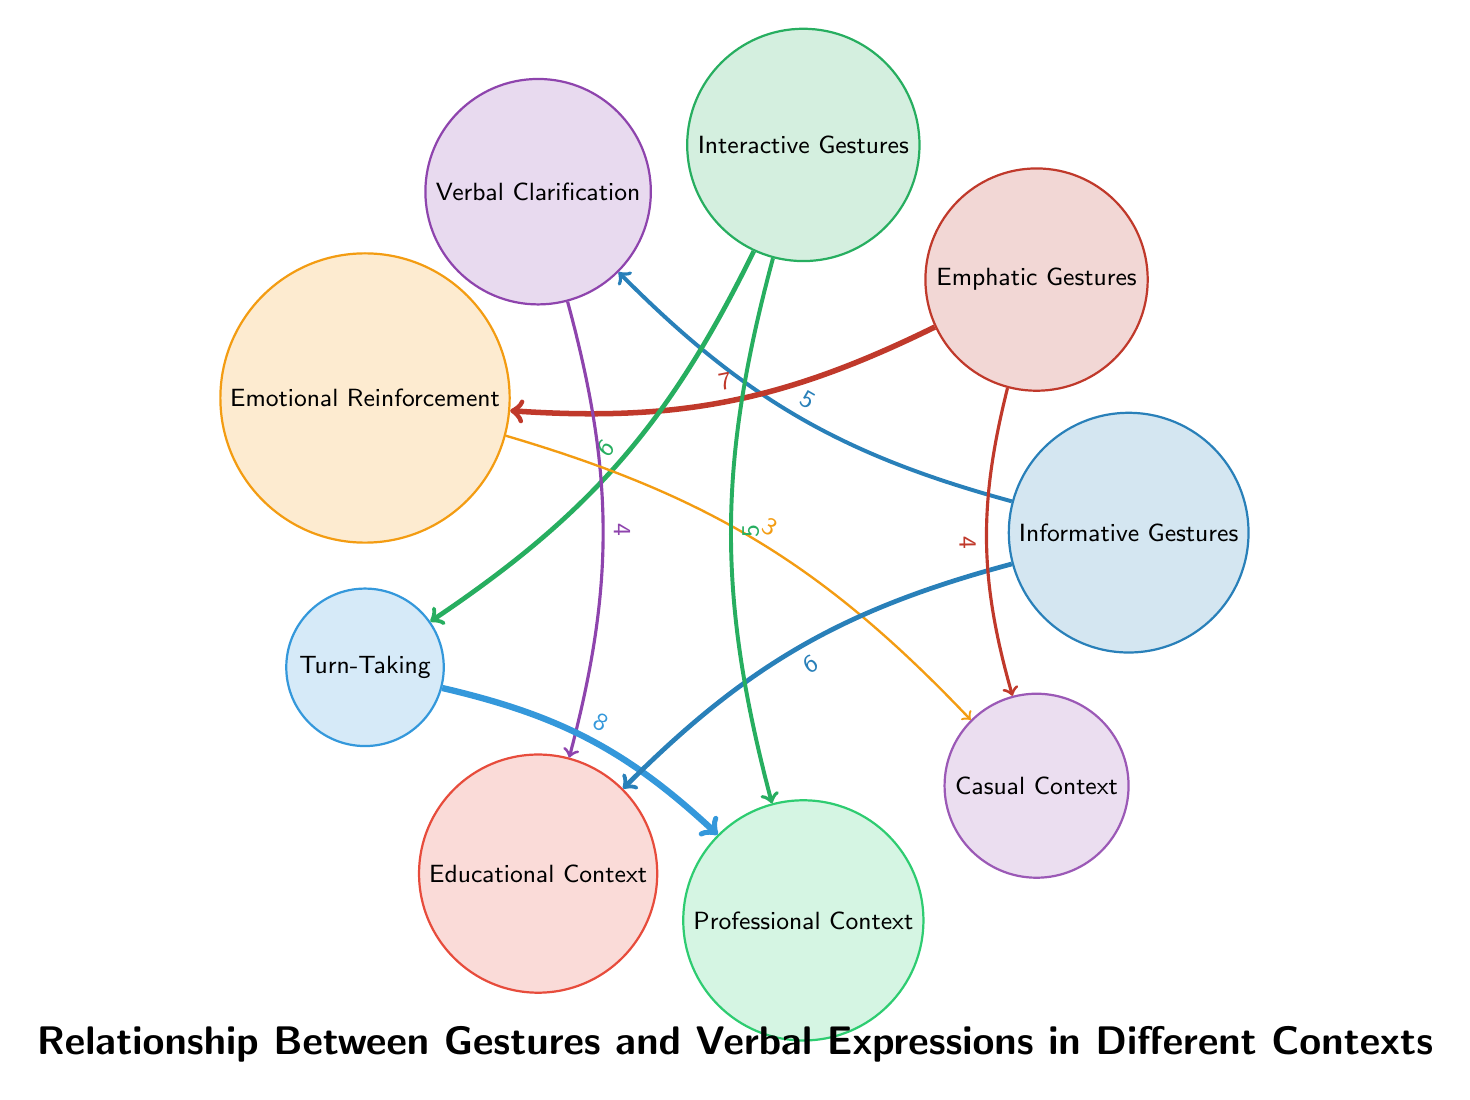What's the value of the link between Informative Gestures and Verbal Clarification? The diagram shows an arrow connecting Informative Gestures to Verbal Clarification with the label "5" on it, indicating the strength of this relationship.
Answer: 5 Which gesture is most associated with Emotional Reinforcement? The arrow between Emphatic Gestures and Emotional Reinforcement is labeled "7," indicating that this gesture has the highest value in this specific relationship.
Answer: Emphatic Gestures How many contexts are shown in the diagram? By counting the different nodes, the contexts identified are Educational Context, Professional Context, and Casual Context, totaling three distinct contexts.
Answer: 3 What is the value of Turn-Taking linked to Professional Context? The link from Turn-Taking to Professional Context has the label "8," suggesting a strong relationship. This value can be found directly on the corresponding arrow between these two nodes.
Answer: 8 Which gesture is linked to Verbal Clarification? The link from Informative Gestures to Verbal Clarification signifies that Informative Gestures are specifically related to this type of verbal expression. The relationship is labeled with a value of "5."
Answer: Informative Gestures Which type of gesture supports Turn-Taking in a Professional Context? The diagram indicates that Interactive Gestures have a link to Turn-Taking as well as a connection to Professional Context, showing that these gestures facilitate this communicative aspect in a professional setting.
Answer: Interactive Gestures What is the total value of links from Emphatic Gestures? By adding the values of the links (7 to Emotional Reinforcement and 4 to Casual Context), the total is 11, indicating the overall associations of Emphatic Gestures within the diagram.
Answer: 11 How does Verbal Clarification connect to the Educational Context? Verbal Clarification has a direct link to Educational Context, which shows the strength of this relationship is indicated by the value 4 on the arrow connecting them.
Answer: 4 Which gesture is least connected to Emotional Reinforcement? The arrow from Emotional Reinforcement to Casual Context is labeled "3," which is the lowest value in relation to Emotional Reinforcement, indicating minimal support for this gesture.
Answer: Emotional Reinforcement 